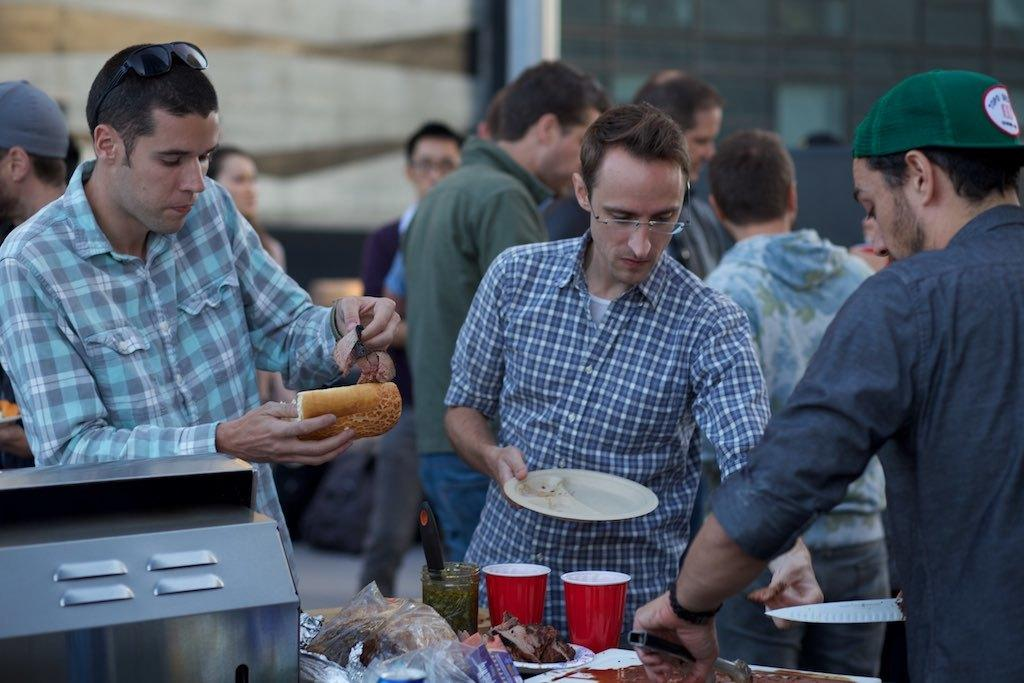How many people are in the image? There are multiple persons in the image. What else can be seen in the image besides the people? There are eatables, covers, and glasses in the image. What are some of the people doing in the image? Some persons are eating in the image. Can you see any fish swimming in the image? There are no fish present in the image. What type of twig is being used as a utensil by the persons in the image? There are no twigs being used as utensils in the image; instead, there are glasses and eatables. 